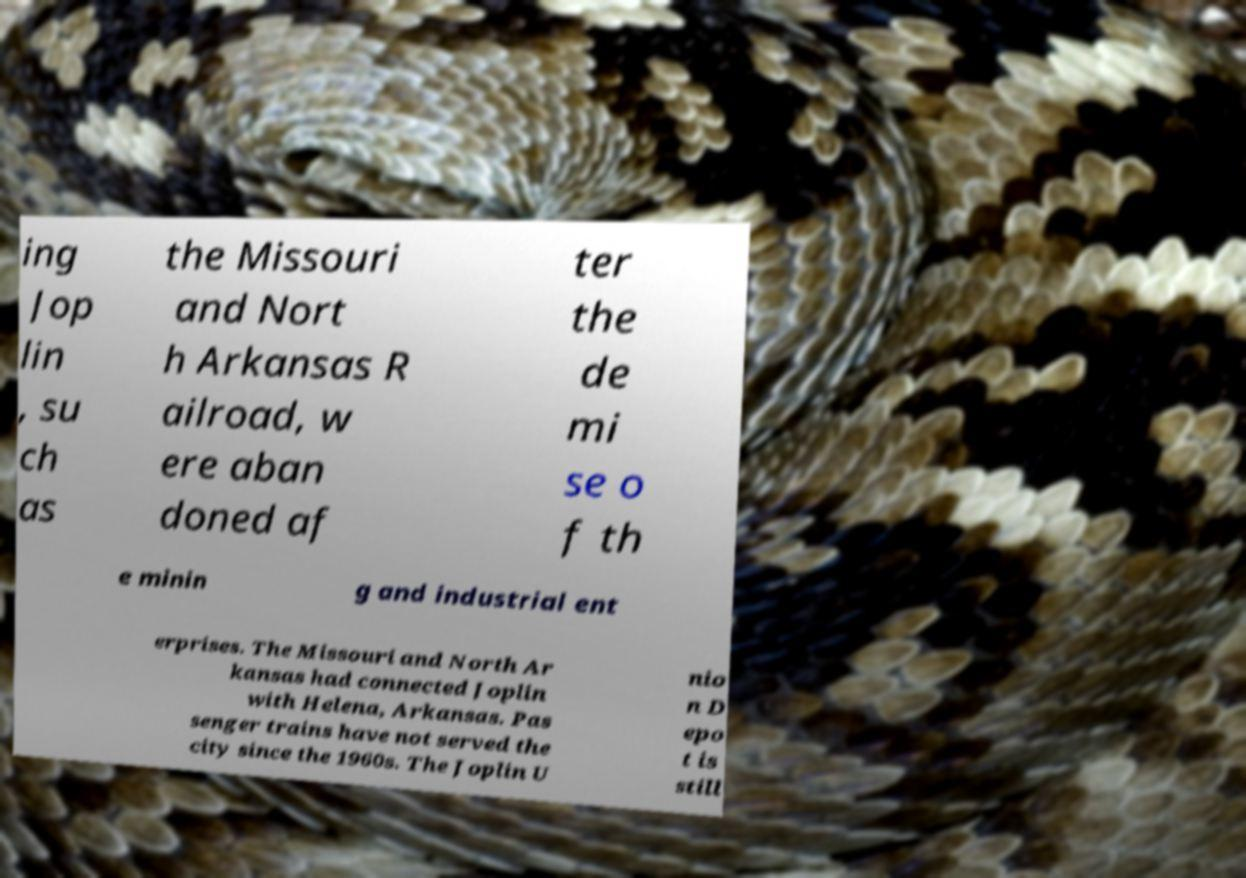I need the written content from this picture converted into text. Can you do that? ing Jop lin , su ch as the Missouri and Nort h Arkansas R ailroad, w ere aban doned af ter the de mi se o f th e minin g and industrial ent erprises. The Missouri and North Ar kansas had connected Joplin with Helena, Arkansas. Pas senger trains have not served the city since the 1960s. The Joplin U nio n D epo t is still 